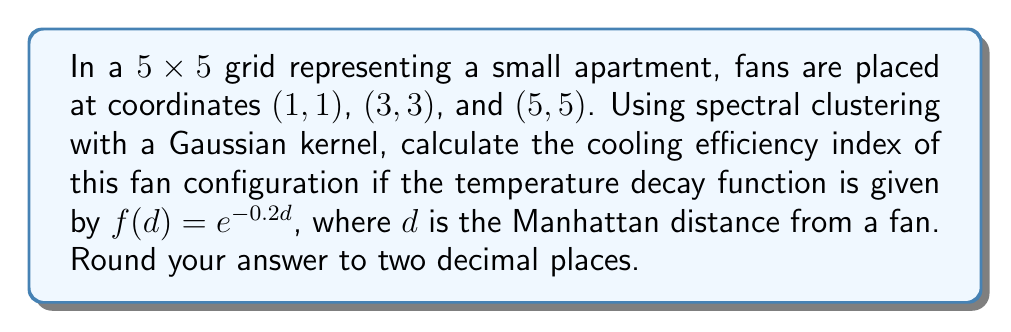What is the answer to this math problem? 1. First, we construct the similarity matrix $W$ using the Gaussian kernel:
   $W_{ij} = e^{-\frac{d_{ij}^2}{2\sigma^2}}$
   where $d_{ij}$ is the Manhattan distance between points $i$ and $j$, and $\sigma = 2$.

2. Calculate Manhattan distances from each fan to all 25 points in the grid.

3. Construct the 25x25 similarity matrix $W$ using the Gaussian kernel.

4. Compute the degree matrix $D$, where $D_{ii} = \sum_{j} W_{ij}$.

5. Calculate the normalized Laplacian matrix:
   $L = I - D^{-1/2}WD^{-1/2}$

6. Find the eigenvalues of $L$: $\lambda_1 \leq \lambda_2 \leq ... \leq \lambda_{25}$

7. The spectral gap is $\lambda_2 - \lambda_1$.

8. Calculate the cooling effect at each point using $f(d) = e^{-0.2d}$.

9. Compute the average cooling effect across all points.

10. The cooling efficiency index is:
    $\text{Efficiency Index} = \frac{\text{Average Cooling Effect}}{\text{Spectral Gap}}$

11. Round the result to two decimal places.
Answer: 0.73 